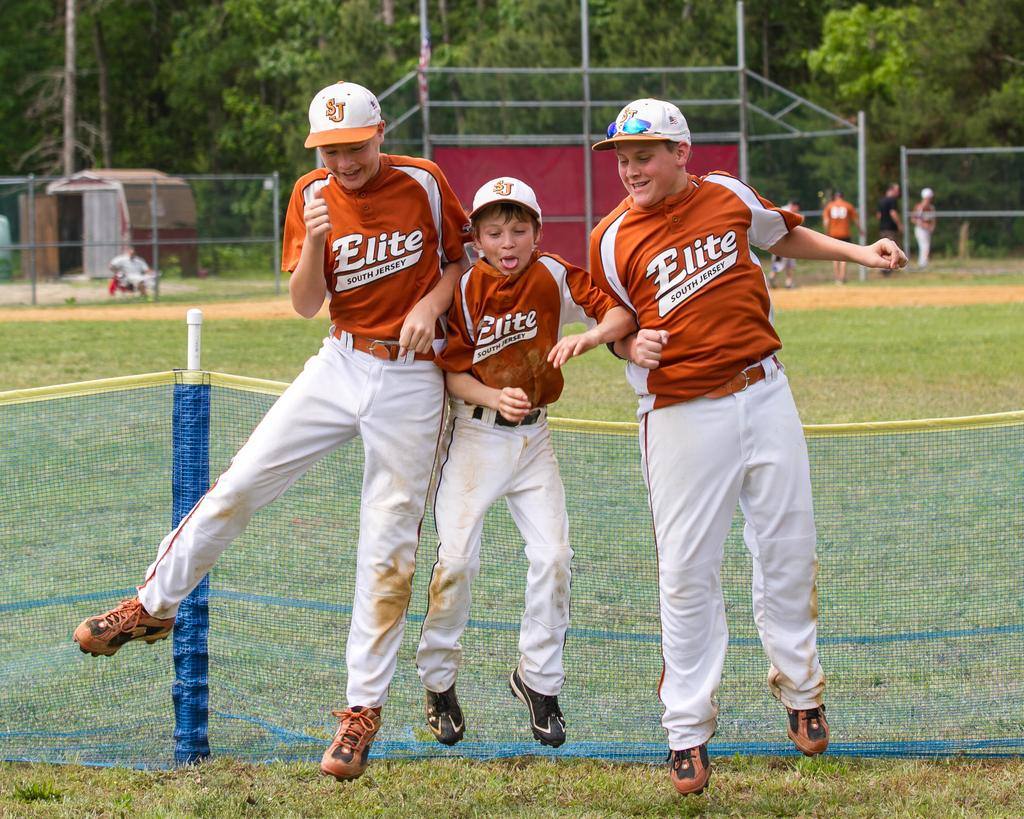<image>
Create a compact narrative representing the image presented. Three members fo the Elite team are goofing around together. 